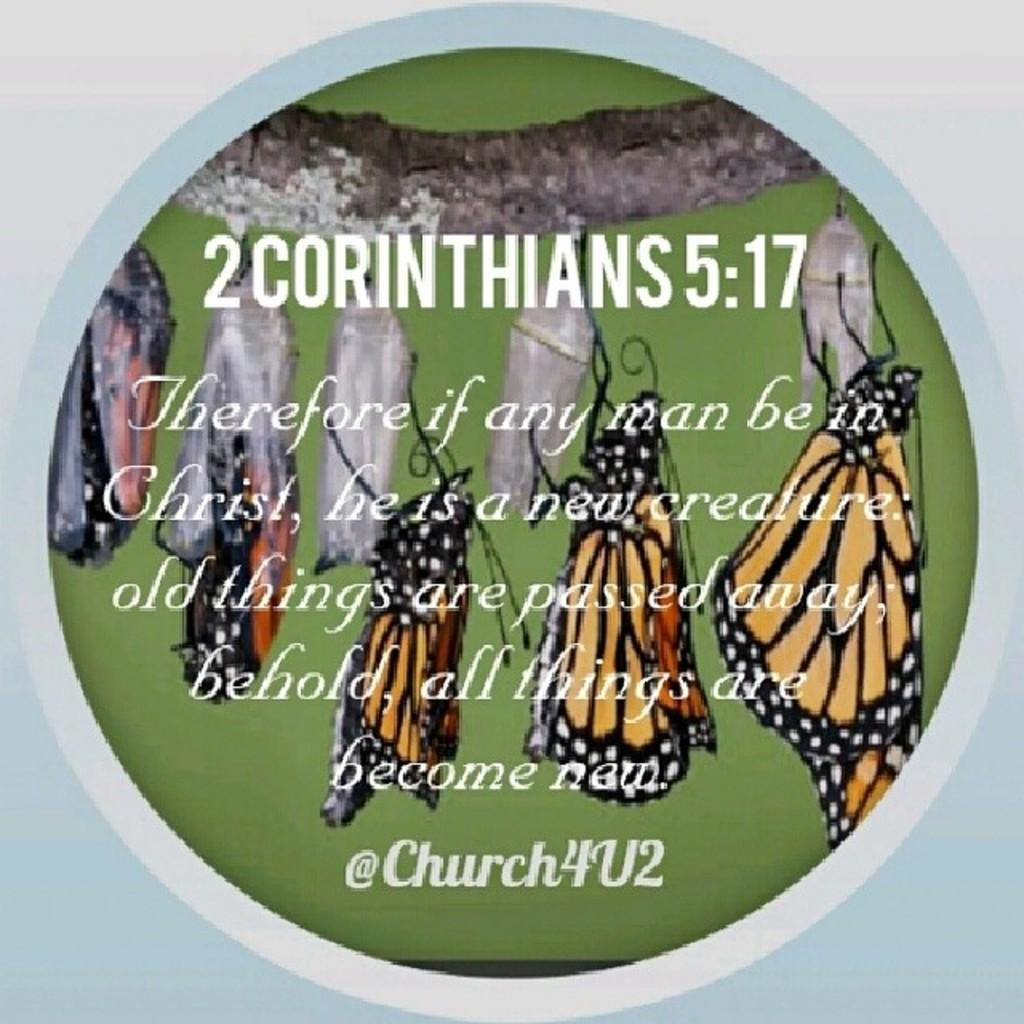What type of visual is depicted in the image? The image is a poster. What creatures are featured on the poster? There are butterflies on the poster. Are there any words or phrases on the poster? Yes, there is text on the poster. What type of camp can be seen in the background of the poster? There is no camp visible in the image; it is a poster featuring butterflies and text. How many yams are present on the poster? There are no yams depicted on the poster; it features butterflies and text. 